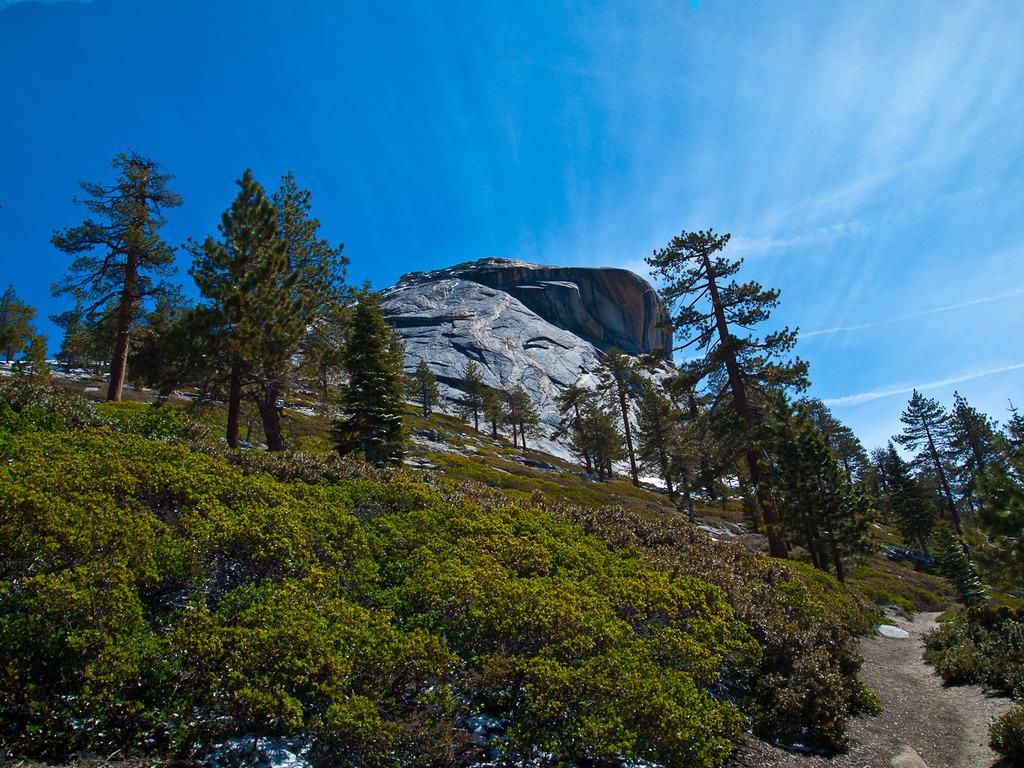What geographical feature is the main subject of the image? There is a mountain in the image. What type of vegetation can be seen in the image? There are plants and trees in the image. What is visible at the top of the mountain in the image? The sky is visible at the top of the mountain in the image. Can you see any fish swimming in the image? There are no fish present in the image. How many jellyfish can be seen floating in the sky in the image? There are no jellyfish present in the image, and the sky is visible at the top of the mountain, not in the sky. 